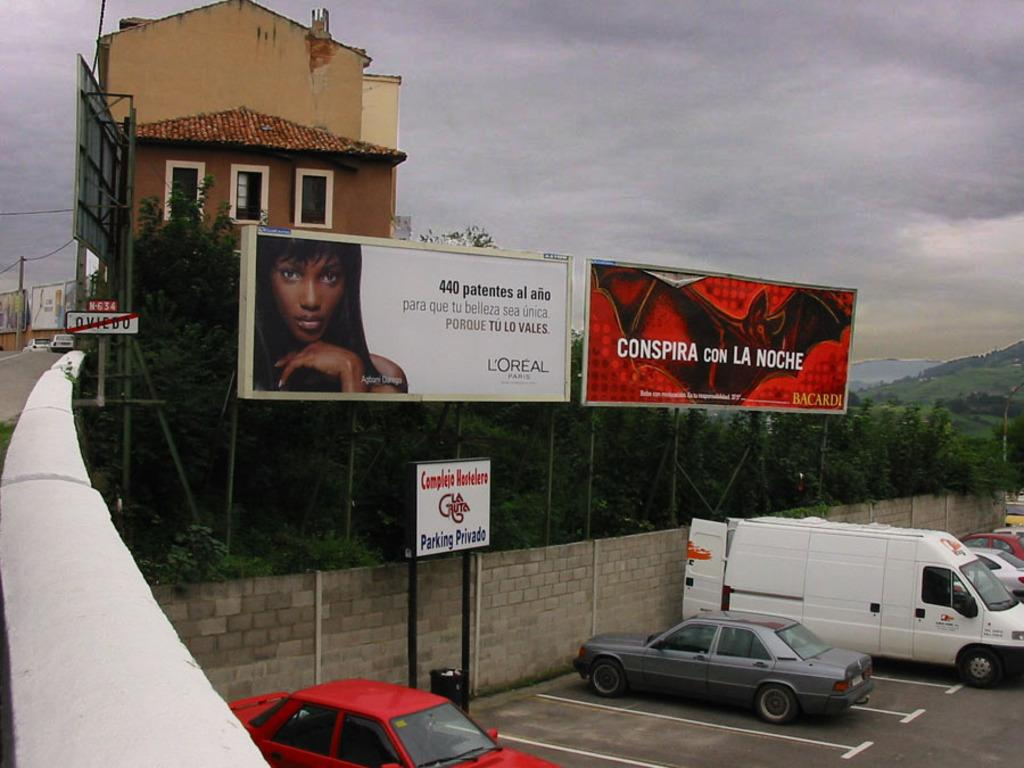<image>
Share a concise interpretation of the image provided. A white sign posted in a parking lot gives notice in Spanish by stating in blue lettering, Parking Privado. 